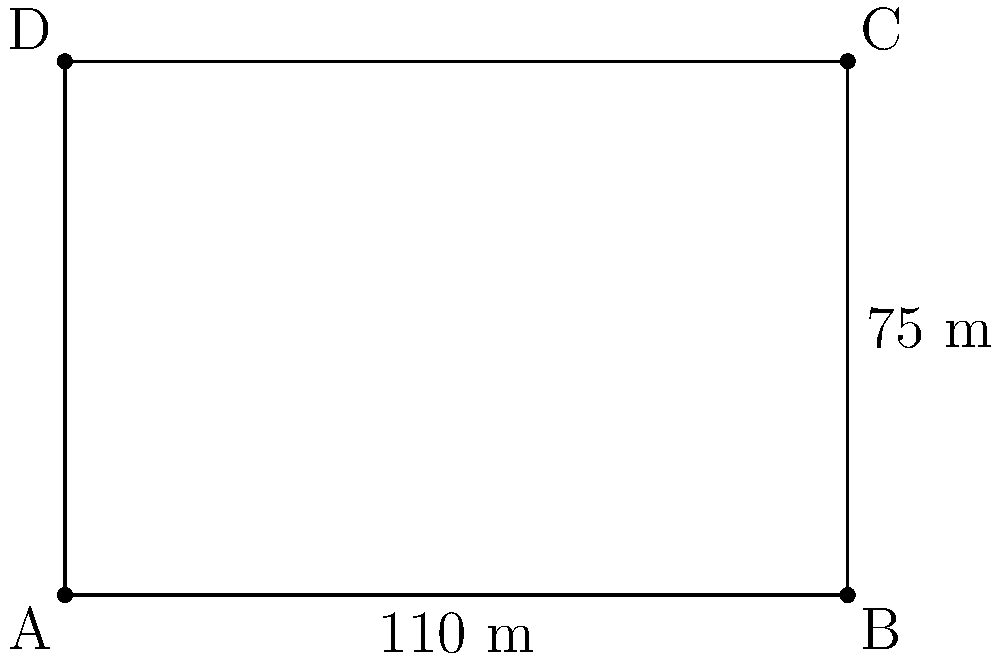During a nostalgic conversation about the Estadio Nacional in Lima, where many memorable matches of the early 2000s were played, you recall that FIFA regulations specify standard pitch dimensions. If the length of the pitch is 110 meters and the width is 75 meters, what is the total area of the playing surface? To calculate the area of the football pitch, we need to follow these steps:

1) The pitch is rectangular in shape, so we can use the formula for the area of a rectangle:

   $$ A = l \times w $$

   Where $A$ is the area, $l$ is the length, and $w$ is the width.

2) We are given:
   - Length ($l$) = 110 meters
   - Width ($w$) = 75 meters

3) Let's substitute these values into our formula:

   $$ A = 110 \times 75 $$

4) Now we can perform the multiplication:

   $$ A = 8,250 $$

5) The result is in square meters ($\text{m}^2$) because we multiplied two lengths together.

Therefore, the total area of the playing surface is 8,250 square meters.
Answer: 8,250 $\text{m}^2$ 